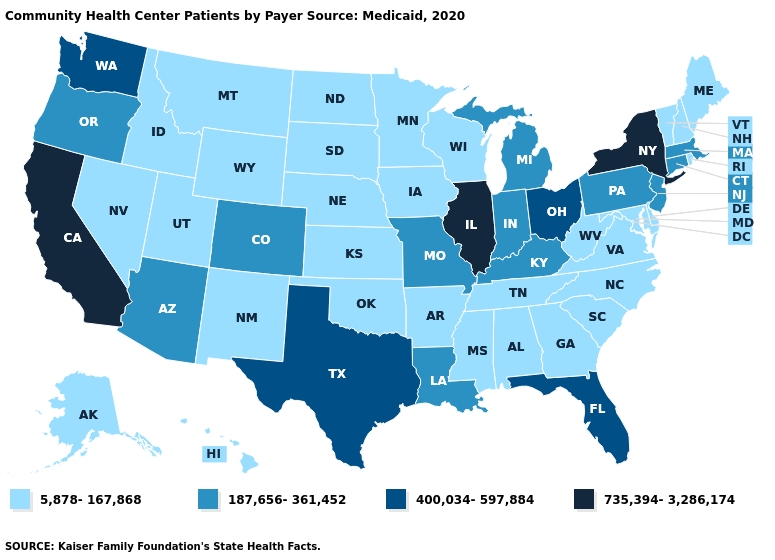Does New Mexico have the highest value in the USA?
Short answer required. No. Does Iowa have the lowest value in the USA?
Answer briefly. Yes. What is the value of Montana?
Keep it brief. 5,878-167,868. Does Alabama have the lowest value in the USA?
Give a very brief answer. Yes. Among the states that border Nebraska , which have the highest value?
Be succinct. Colorado, Missouri. Is the legend a continuous bar?
Quick response, please. No. What is the value of North Carolina?
Give a very brief answer. 5,878-167,868. Among the states that border Missouri , which have the lowest value?
Give a very brief answer. Arkansas, Iowa, Kansas, Nebraska, Oklahoma, Tennessee. Which states have the lowest value in the USA?
Keep it brief. Alabama, Alaska, Arkansas, Delaware, Georgia, Hawaii, Idaho, Iowa, Kansas, Maine, Maryland, Minnesota, Mississippi, Montana, Nebraska, Nevada, New Hampshire, New Mexico, North Carolina, North Dakota, Oklahoma, Rhode Island, South Carolina, South Dakota, Tennessee, Utah, Vermont, Virginia, West Virginia, Wisconsin, Wyoming. How many symbols are there in the legend?
Give a very brief answer. 4. What is the highest value in the West ?
Keep it brief. 735,394-3,286,174. What is the highest value in states that border Connecticut?
Short answer required. 735,394-3,286,174. Among the states that border Kansas , does Oklahoma have the highest value?
Short answer required. No. Among the states that border Nevada , does Oregon have the highest value?
Keep it brief. No. Does Iowa have the highest value in the MidWest?
Keep it brief. No. 